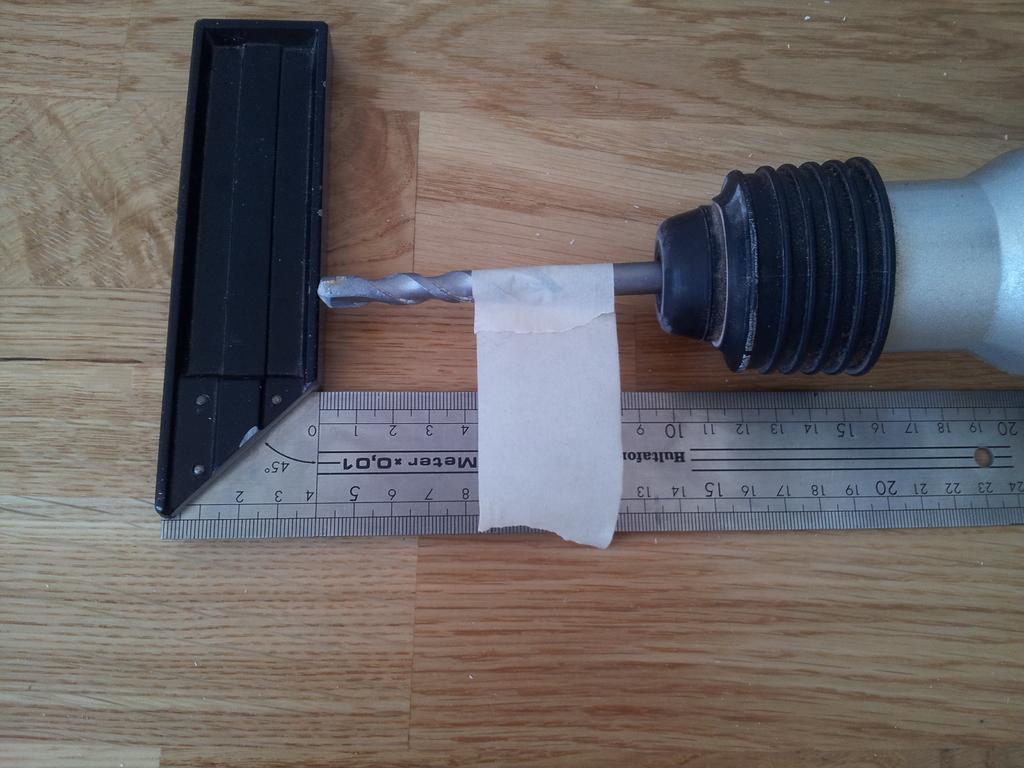What is the length measurement?
Give a very brief answer. 4.5. 